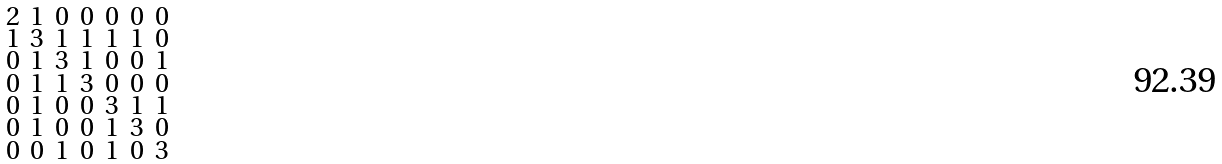Convert formula to latex. <formula><loc_0><loc_0><loc_500><loc_500>\begin{smallmatrix} 2 & 1 & 0 & 0 & 0 & 0 & 0 \\ 1 & 3 & 1 & 1 & 1 & 1 & 0 \\ 0 & 1 & 3 & 1 & 0 & 0 & 1 \\ 0 & 1 & 1 & 3 & 0 & 0 & 0 \\ 0 & 1 & 0 & 0 & 3 & 1 & 1 \\ 0 & 1 & 0 & 0 & 1 & 3 & 0 \\ 0 & 0 & 1 & 0 & 1 & 0 & 3 \end{smallmatrix}</formula> 